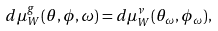Convert formula to latex. <formula><loc_0><loc_0><loc_500><loc_500>d \mu _ { W } ^ { g } ( \theta , \phi , \omega ) = d \mu _ { W } ^ { \nu } ( \theta _ { \omega } , \phi _ { \omega } ) ,</formula> 